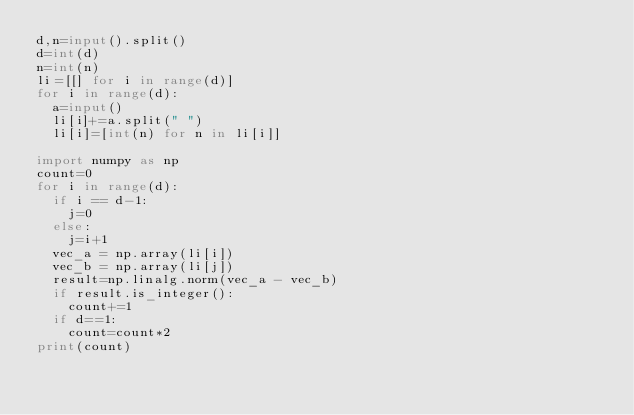Convert code to text. <code><loc_0><loc_0><loc_500><loc_500><_Python_>d,n=input().split()
d=int(d)
n=int(n)
li=[[] for i in range(d)]
for i in range(d):
  a=input()
  li[i]+=a.split(" ")
  li[i]=[int(n) for n in li[i]]
 
import numpy as np
count=0
for i in range(d):
  if i == d-1:
    j=0
  else:
    j=i+1
  vec_a = np.array(li[i])
  vec_b = np.array(li[j])
  result=np.linalg.norm(vec_a - vec_b)
  if result.is_integer():
    count+=1
  if d==1:
    count=count*2
print(count)
</code> 